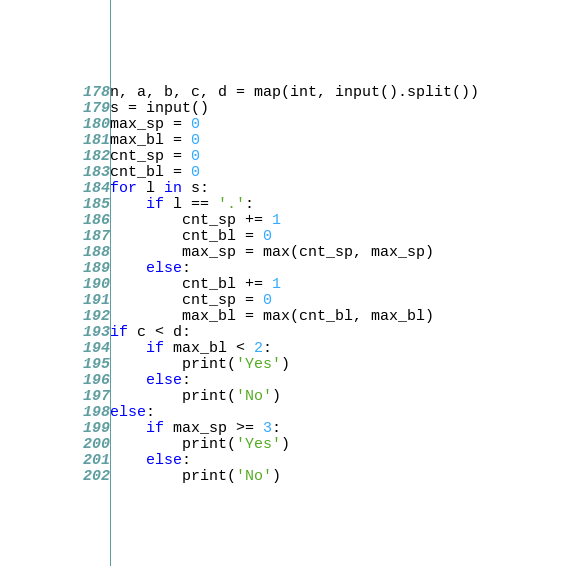Convert code to text. <code><loc_0><loc_0><loc_500><loc_500><_Python_>n, a, b, c, d = map(int, input().split())
s = input()
max_sp = 0
max_bl = 0
cnt_sp = 0
cnt_bl = 0
for l in s:
    if l == '.':
        cnt_sp += 1
        cnt_bl = 0
        max_sp = max(cnt_sp, max_sp)
    else:
        cnt_bl += 1
        cnt_sp = 0
        max_bl = max(cnt_bl, max_bl)
if c < d:
    if max_bl < 2:
        print('Yes')
    else:
        print('No')
else:
    if max_sp >= 3:
        print('Yes')
    else:
        print('No')</code> 